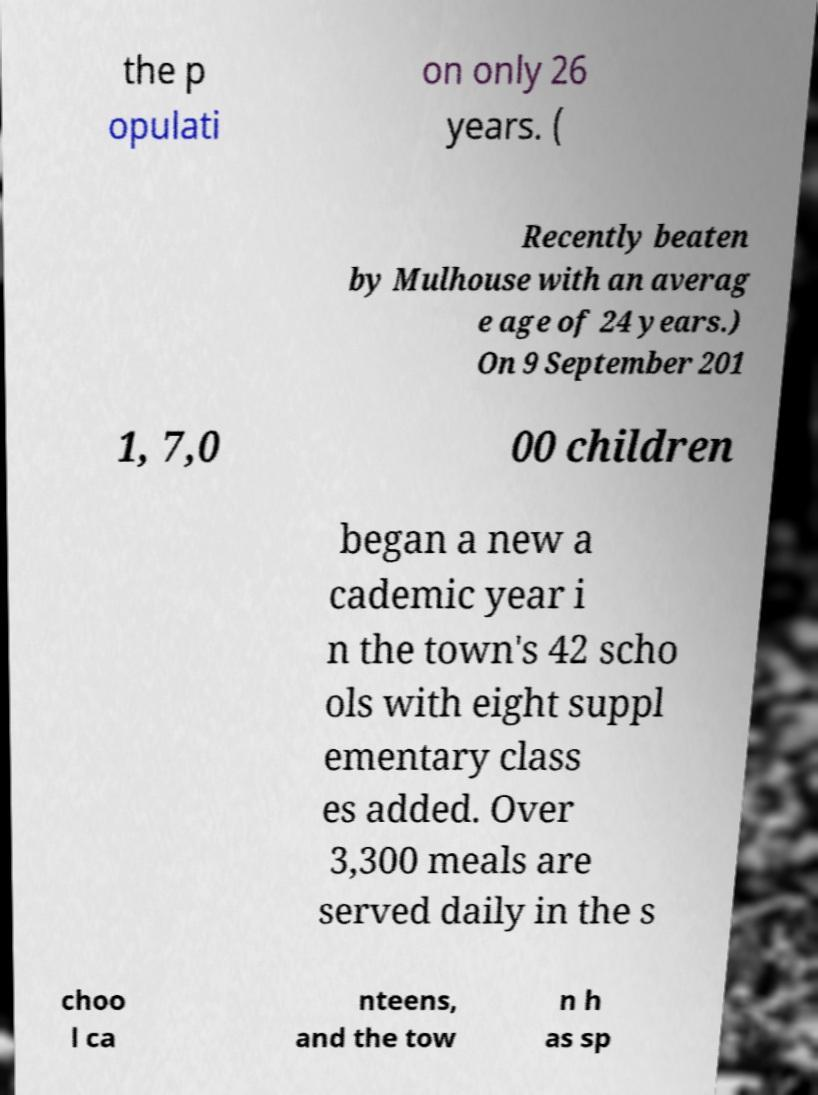What messages or text are displayed in this image? I need them in a readable, typed format. the p opulati on only 26 years. ( Recently beaten by Mulhouse with an averag e age of 24 years.) On 9 September 201 1, 7,0 00 children began a new a cademic year i n the town's 42 scho ols with eight suppl ementary class es added. Over 3,300 meals are served daily in the s choo l ca nteens, and the tow n h as sp 